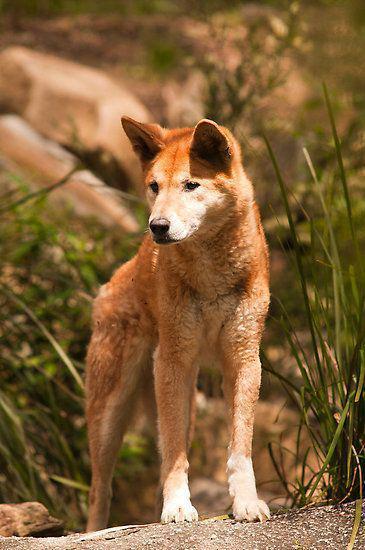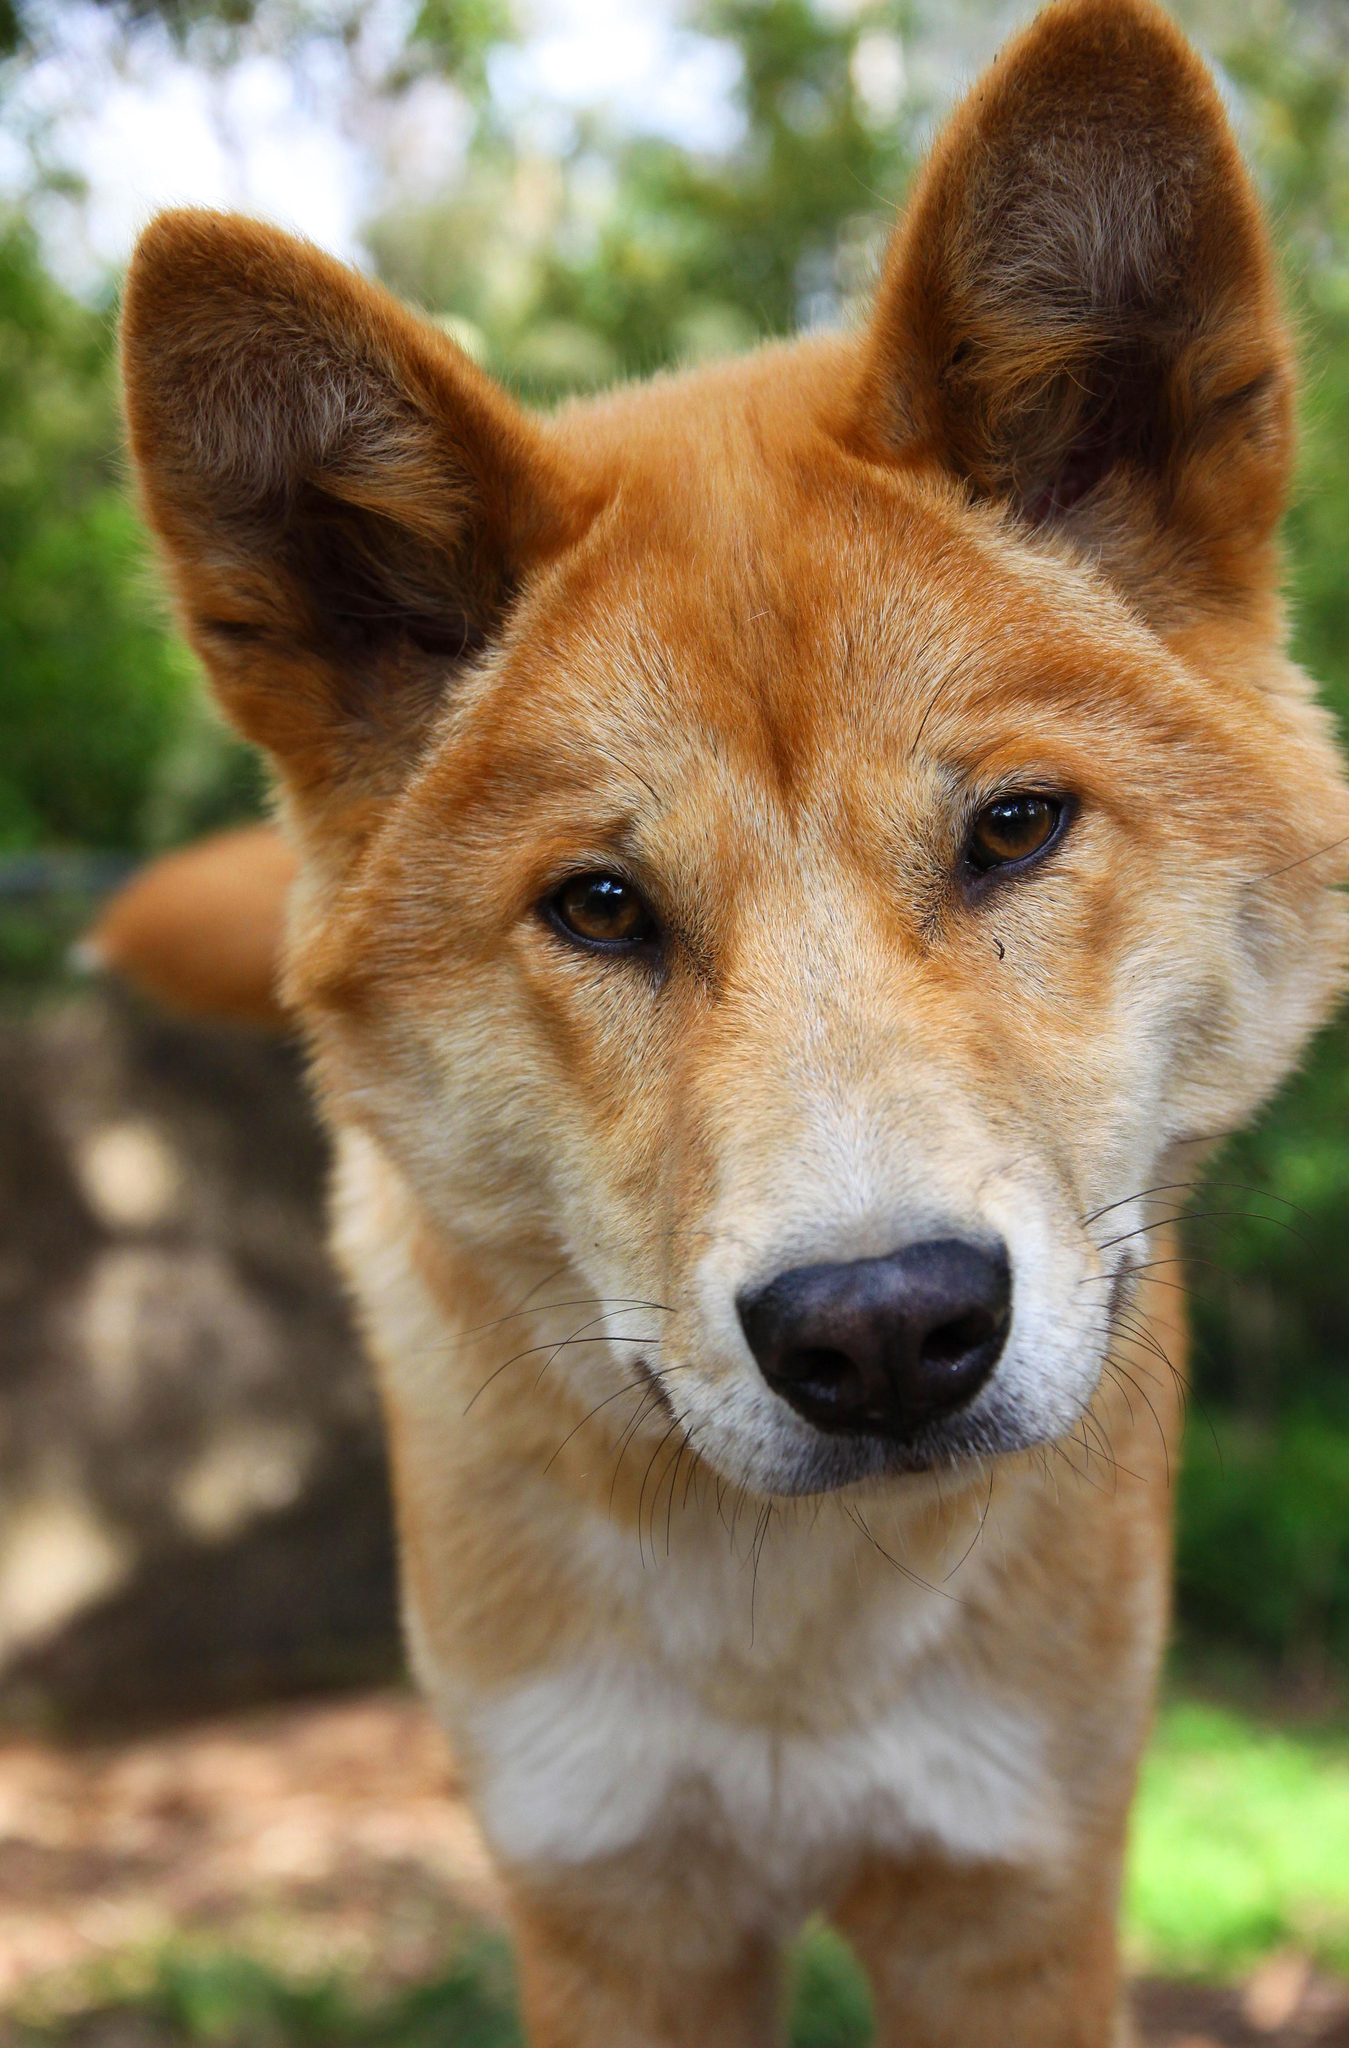The first image is the image on the left, the second image is the image on the right. Evaluate the accuracy of this statement regarding the images: "There are at most 3 dingos in the image pair". Is it true? Answer yes or no. Yes. The first image is the image on the left, the second image is the image on the right. For the images displayed, is the sentence "The right image contains at least two dingoes." factually correct? Answer yes or no. No. 